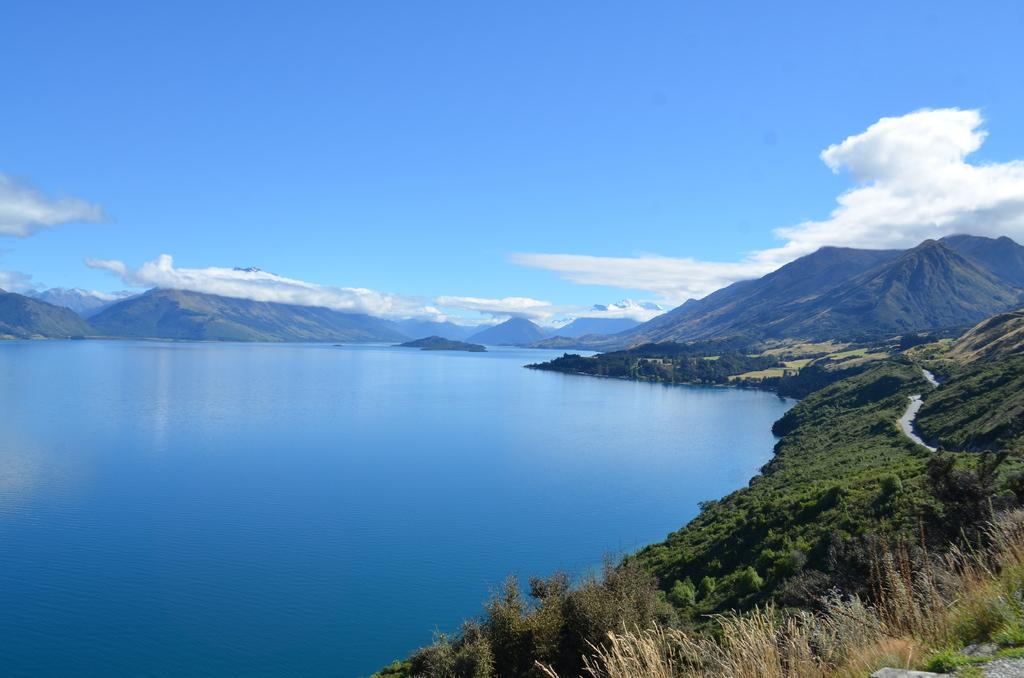What type of natural feature is located on the left side of the image? There is a river on the left side of the image. What type of vegetation is on the right side of the image? There are trees and grass on the right side of the image. What can be seen in the background of the image? There are mountains and the sky visible in the background of the image. Is there an island visible in the image? There is no island present in the image. What type of vacation destination is depicted in the image? The image does not depict a specific vacation destination; it shows a natural landscape with a river, trees, grass, mountains, and sky. 